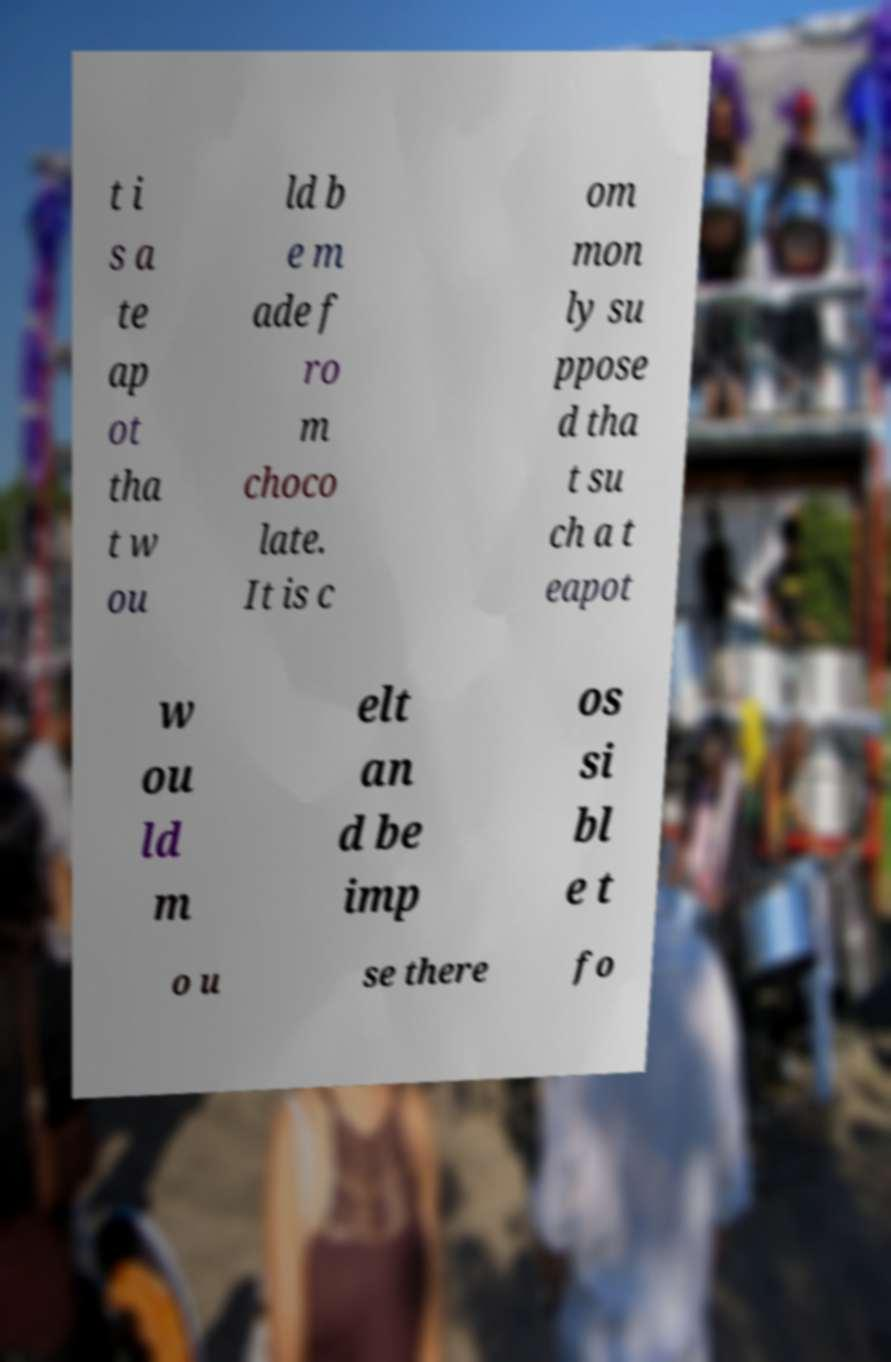Could you extract and type out the text from this image? t i s a te ap ot tha t w ou ld b e m ade f ro m choco late. It is c om mon ly su ppose d tha t su ch a t eapot w ou ld m elt an d be imp os si bl e t o u se there fo 